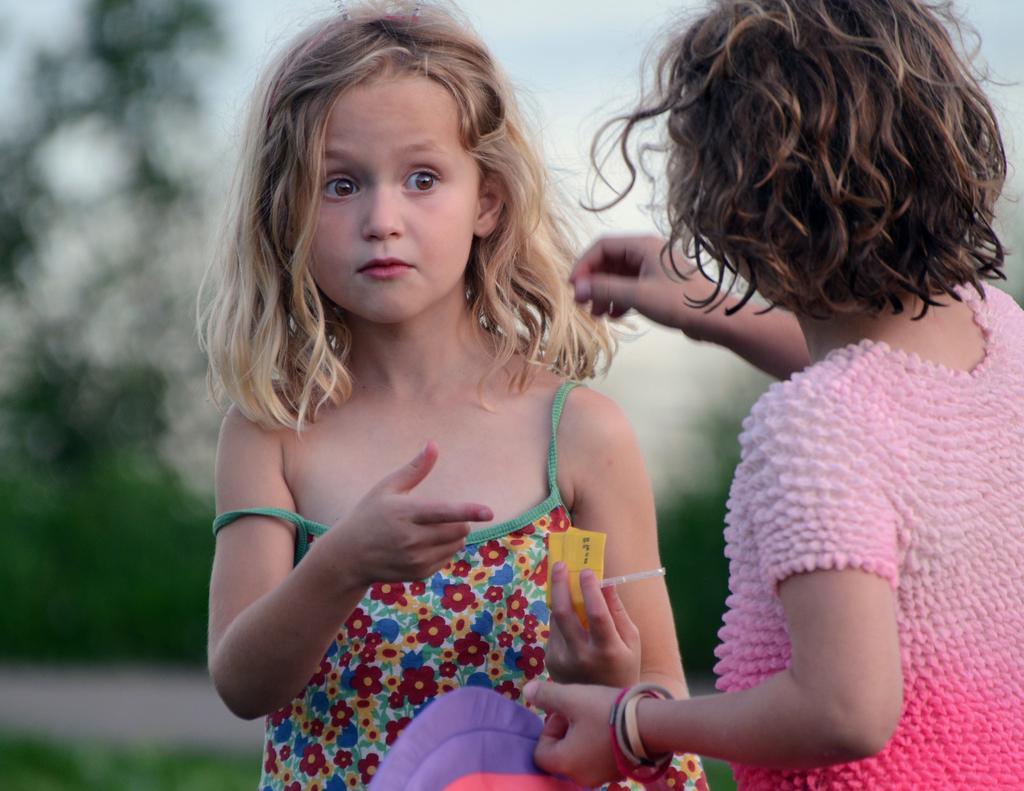Can you describe this image briefly? In this image we can see a girl holding an object. We can also see another girl standing. The background is blurred. 